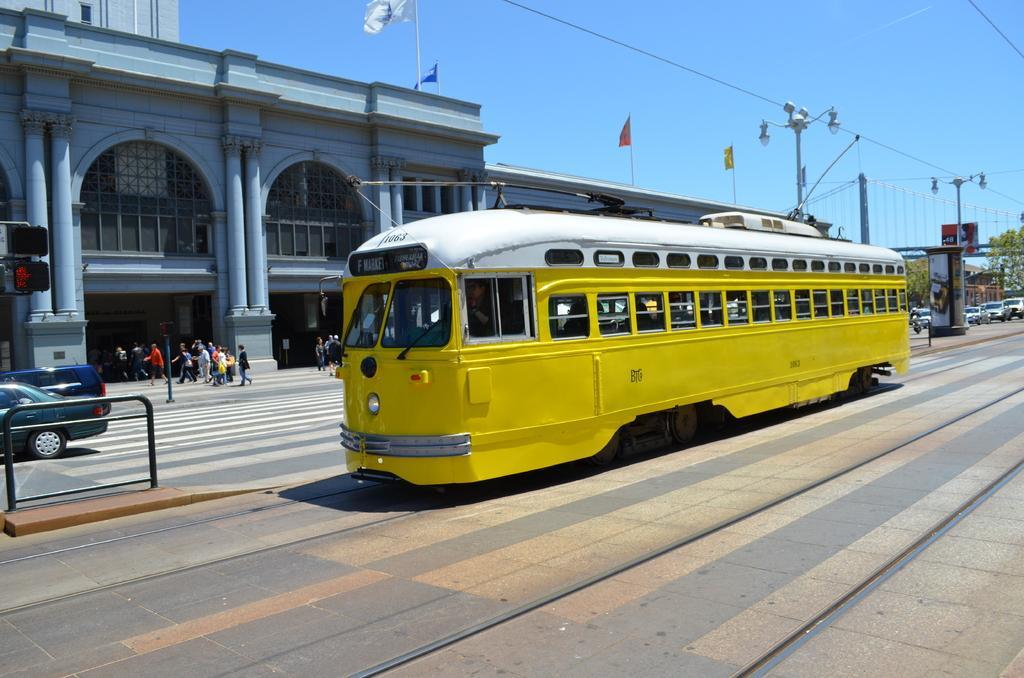Please provide a concise description of this image. In this image there is a train on the railway track , buildings, group of people, vehicles on the road, flags with the poles, lights, trees, and in the background there is sky. 